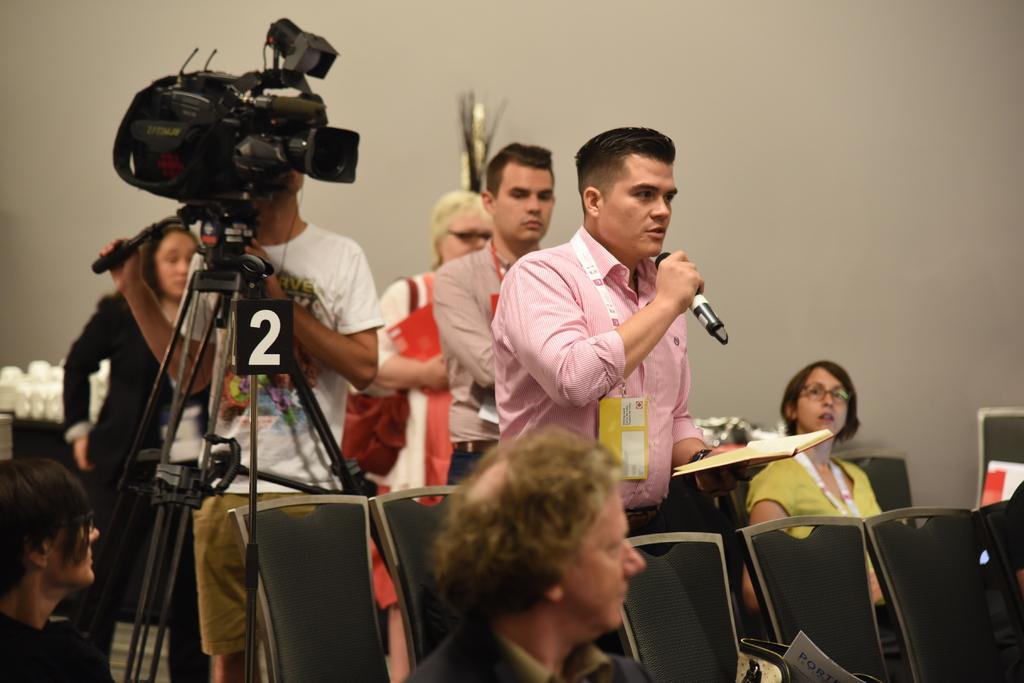Describe this image in one or two sentences. In this image there is a person standing and holding a mike in one hand and in the other hand he is holding a book, behind him there are a few people standing, one of them is shooting with a camera, beside him there is girl sat on the chair, in front of him there is another woman sat on the chair. In the background there is a wall. 